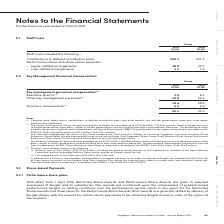According to Singapore Telecommunications's financial document, What does key management personnel compensation comprise? Comprise base salary, bonus, contributions to defined contribution plans and other benefits, but exclude performance share and share option expenses disclosed below.. The document states: "(1) Comprise base salary, bonus, contributions to defined contribution plans and other benefits, but exclude performance share and share option expens..." Also, What does directors' remuneration comprise of? The document shows two values: Directors’ fees and Car-related benefits of the Chairman. From the document: "and as director of Singtel Innov8 Pte. Ltd. (ii) Car-related benefits of the Chairman of S$24,557 (2018: S$20,446). In addition to the Directors’ remu..." Also, How many ordinary shares of Singtel was the Group Chief Executive Officer awarded in 2019? According to the financial document, up to 1,030,168. The relevant text states: "er, an executive director of Singtel, was awarded up to 1,030,168 (2018: 1,712,538) ordinary shares of Singtel pursuant to Singtel performance share plans, subject t..." Also, can you calculate: What is the % change in key management personnel compensation from 2018 to 2019, excluding directors' remuneration? To answer this question, I need to perform calculations using the financial data. The calculation is: (19.4 - 28.5) / 28.5, which equals -31.93 (percentage). This is based on the information: "Other key management personnel (3) 15.9 22.4 19.4 28.5 Directors’ remuneration (4) 2.7 2.5 6.1 Other key management personnel (3) 15.9 22.4 19.4 28.5 Directors’ remuneration (4) 2.7 2.5..." The key data points involved are: 19.4, 28.5. Also, How many subcategories are there that make up key management personnel compensation? Counting the relevant items in the document: Executive director, Other key management personnel, Directors' remuneration, I find 3 instances. The key data points involved are: Directors' remuneration, Executive director, Other key management personnel. Also, Under other key management personnel of the group, how many executive directors are included? Counting the relevant items in the document: Chief Executive Officers of Consumer Singapore, Consumer Australia, Group Enterprise, Group Digital Life, International Group, Group Chief Corporate Officer, Group Chief Financial Officer, Group Chief Human Resources Officer, Group Chief Information Officer, Group Chief Technology Officer, I find 10 instances. The key data points involved are: Chief Executive Officers of Consumer Singapore, Consumer Australia, Group Chief Corporate Officer. 